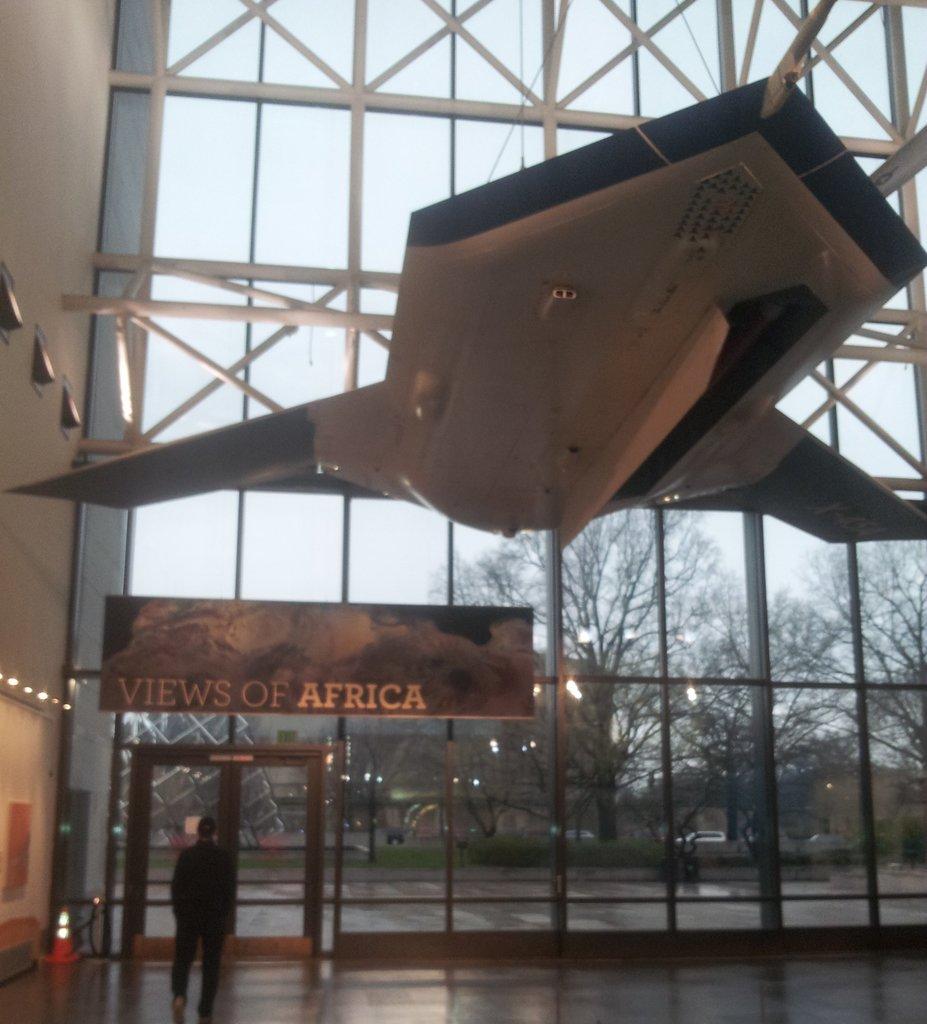What is the name of the exhibition?
Your response must be concise. Views of africa. What kind of view is advertised?
Provide a succinct answer. Africa. 